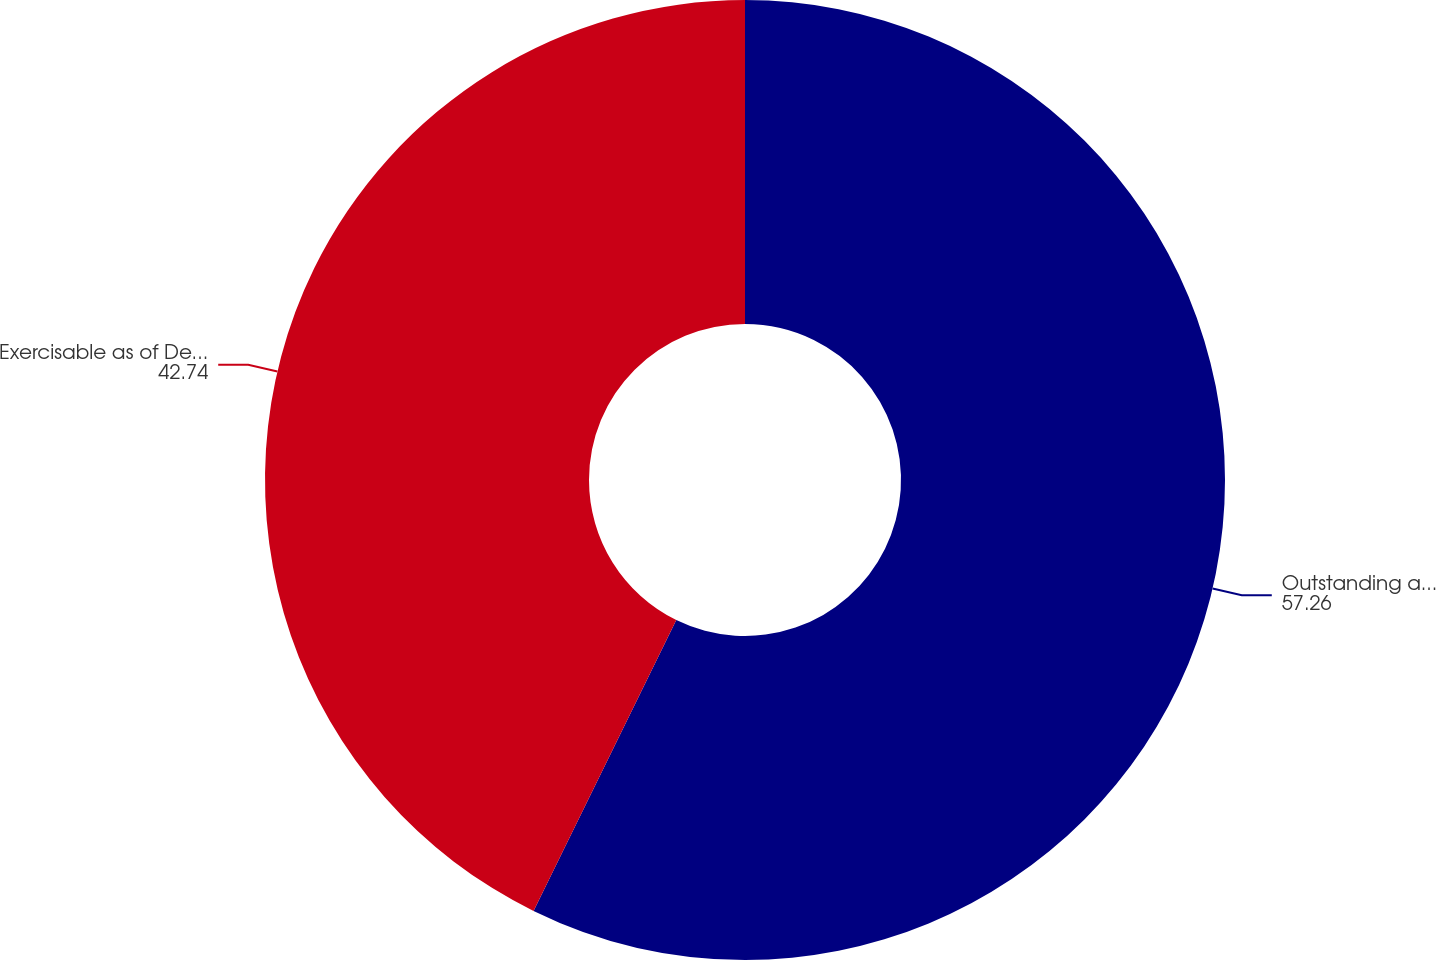Convert chart. <chart><loc_0><loc_0><loc_500><loc_500><pie_chart><fcel>Outstanding as of December 31<fcel>Exercisable as of December 31<nl><fcel>57.26%<fcel>42.74%<nl></chart> 